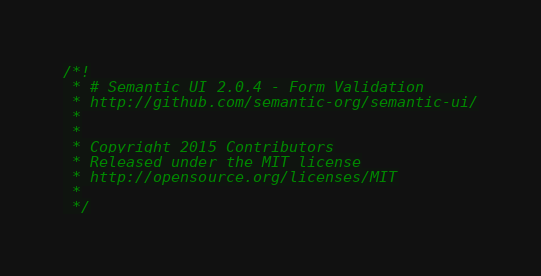<code> <loc_0><loc_0><loc_500><loc_500><_JavaScript_>/*!
 * # Semantic UI 2.0.4 - Form Validation
 * http://github.com/semantic-org/semantic-ui/
 *
 *
 * Copyright 2015 Contributors
 * Released under the MIT license
 * http://opensource.org/licenses/MIT
 *
 */</code> 